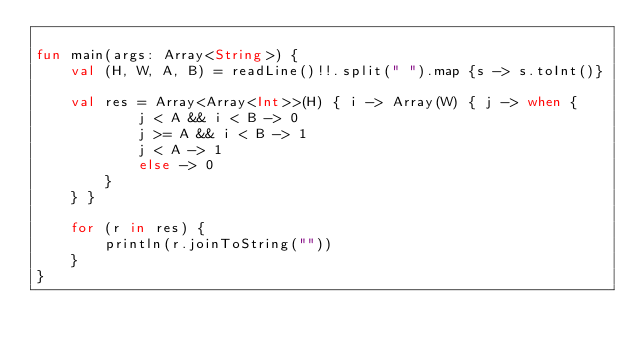Convert code to text. <code><loc_0><loc_0><loc_500><loc_500><_Kotlin_>
fun main(args: Array<String>) {
    val (H, W, A, B) = readLine()!!.split(" ").map {s -> s.toInt()}

    val res = Array<Array<Int>>(H) { i -> Array(W) { j -> when {
            j < A && i < B -> 0
            j >= A && i < B -> 1
            j < A -> 1
            else -> 0
        }
    } }

    for (r in res) {
        println(r.joinToString(""))
    }
}</code> 